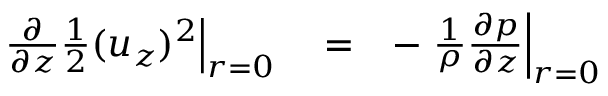<formula> <loc_0><loc_0><loc_500><loc_500>\begin{array} { r l r } { { \frac { \partial } { \partial z } \frac { 1 } { 2 } ( u _ { z } ) ^ { 2 } } \right | _ { r = 0 } } & = } & { - { \frac { 1 } { \rho } \frac { \partial p } { \partial z } } \right | _ { r = 0 } } \end{array}</formula> 